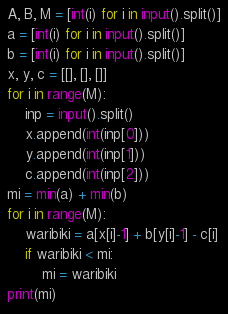<code> <loc_0><loc_0><loc_500><loc_500><_Python_>A, B, M = [int(i) for i in input().split()]
a = [int(i) for i in input().split()]
b = [int(i) for i in input().split()]
x, y, c = [[], [], []]
for i in range(M):
    inp = input().split()
    x.append(int(inp[0]))
    y.append(int(inp[1]))
    c.append(int(inp[2]))
mi = min(a) + min(b)
for i in range(M):
    waribiki = a[x[i]-1] + b[y[i]-1] - c[i]
    if waribiki < mi:
        mi = waribiki
print(mi)</code> 